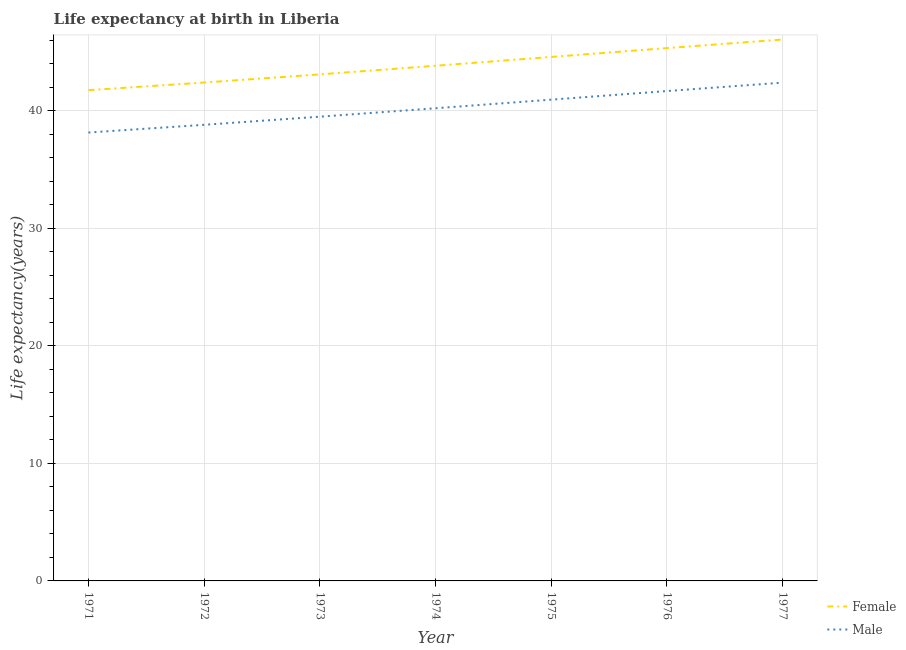How many different coloured lines are there?
Keep it short and to the point. 2. Does the line corresponding to life expectancy(male) intersect with the line corresponding to life expectancy(female)?
Give a very brief answer. No. What is the life expectancy(male) in 1975?
Your answer should be very brief. 40.95. Across all years, what is the maximum life expectancy(male)?
Your answer should be very brief. 42.4. Across all years, what is the minimum life expectancy(female)?
Ensure brevity in your answer.  41.76. In which year was the life expectancy(female) minimum?
Offer a very short reply. 1971. What is the total life expectancy(female) in the graph?
Make the answer very short. 307.11. What is the difference between the life expectancy(female) in 1976 and that in 1977?
Provide a succinct answer. -0.73. What is the difference between the life expectancy(female) in 1974 and the life expectancy(male) in 1975?
Keep it short and to the point. 2.89. What is the average life expectancy(female) per year?
Offer a terse response. 43.87. In the year 1972, what is the difference between the life expectancy(male) and life expectancy(female)?
Make the answer very short. -3.6. What is the ratio of the life expectancy(female) in 1972 to that in 1975?
Keep it short and to the point. 0.95. Is the life expectancy(male) in 1973 less than that in 1975?
Your answer should be compact. Yes. What is the difference between the highest and the second highest life expectancy(male)?
Your answer should be very brief. 0.72. What is the difference between the highest and the lowest life expectancy(female)?
Offer a terse response. 4.31. In how many years, is the life expectancy(male) greater than the average life expectancy(male) taken over all years?
Ensure brevity in your answer.  3. Does the life expectancy(female) monotonically increase over the years?
Keep it short and to the point. Yes. Is the life expectancy(female) strictly greater than the life expectancy(male) over the years?
Provide a succinct answer. Yes. How many years are there in the graph?
Provide a short and direct response. 7. What is the difference between two consecutive major ticks on the Y-axis?
Your answer should be very brief. 10. Are the values on the major ticks of Y-axis written in scientific E-notation?
Offer a terse response. No. Does the graph contain grids?
Provide a short and direct response. Yes. Where does the legend appear in the graph?
Provide a short and direct response. Bottom right. How are the legend labels stacked?
Provide a succinct answer. Vertical. What is the title of the graph?
Provide a succinct answer. Life expectancy at birth in Liberia. Does "Net National savings" appear as one of the legend labels in the graph?
Your response must be concise. No. What is the label or title of the X-axis?
Give a very brief answer. Year. What is the label or title of the Y-axis?
Make the answer very short. Life expectancy(years). What is the Life expectancy(years) of Female in 1971?
Give a very brief answer. 41.76. What is the Life expectancy(years) in Male in 1971?
Your answer should be compact. 38.16. What is the Life expectancy(years) of Female in 1972?
Your answer should be compact. 42.41. What is the Life expectancy(years) in Male in 1972?
Ensure brevity in your answer.  38.81. What is the Life expectancy(years) in Female in 1973?
Provide a short and direct response. 43.1. What is the Life expectancy(years) in Male in 1973?
Offer a very short reply. 39.5. What is the Life expectancy(years) of Female in 1974?
Make the answer very short. 43.84. What is the Life expectancy(years) of Male in 1974?
Offer a terse response. 40.22. What is the Life expectancy(years) of Female in 1975?
Give a very brief answer. 44.59. What is the Life expectancy(years) of Male in 1975?
Ensure brevity in your answer.  40.95. What is the Life expectancy(years) of Female in 1976?
Give a very brief answer. 45.34. What is the Life expectancy(years) in Male in 1976?
Provide a short and direct response. 41.69. What is the Life expectancy(years) of Female in 1977?
Provide a succinct answer. 46.07. What is the Life expectancy(years) of Male in 1977?
Offer a very short reply. 42.4. Across all years, what is the maximum Life expectancy(years) in Female?
Keep it short and to the point. 46.07. Across all years, what is the maximum Life expectancy(years) of Male?
Make the answer very short. 42.4. Across all years, what is the minimum Life expectancy(years) in Female?
Offer a very short reply. 41.76. Across all years, what is the minimum Life expectancy(years) in Male?
Your answer should be compact. 38.16. What is the total Life expectancy(years) in Female in the graph?
Ensure brevity in your answer.  307.11. What is the total Life expectancy(years) of Male in the graph?
Your answer should be compact. 281.73. What is the difference between the Life expectancy(years) in Female in 1971 and that in 1972?
Provide a succinct answer. -0.65. What is the difference between the Life expectancy(years) in Male in 1971 and that in 1972?
Make the answer very short. -0.66. What is the difference between the Life expectancy(years) in Female in 1971 and that in 1973?
Provide a succinct answer. -1.34. What is the difference between the Life expectancy(years) in Male in 1971 and that in 1973?
Offer a terse response. -1.35. What is the difference between the Life expectancy(years) in Female in 1971 and that in 1974?
Your answer should be very brief. -2.08. What is the difference between the Life expectancy(years) in Male in 1971 and that in 1974?
Make the answer very short. -2.06. What is the difference between the Life expectancy(years) of Female in 1971 and that in 1975?
Your response must be concise. -2.83. What is the difference between the Life expectancy(years) in Male in 1971 and that in 1975?
Make the answer very short. -2.8. What is the difference between the Life expectancy(years) of Female in 1971 and that in 1976?
Your answer should be compact. -3.58. What is the difference between the Life expectancy(years) of Male in 1971 and that in 1976?
Make the answer very short. -3.53. What is the difference between the Life expectancy(years) in Female in 1971 and that in 1977?
Provide a succinct answer. -4.31. What is the difference between the Life expectancy(years) in Male in 1971 and that in 1977?
Offer a very short reply. -4.25. What is the difference between the Life expectancy(years) in Female in 1972 and that in 1973?
Make the answer very short. -0.7. What is the difference between the Life expectancy(years) in Male in 1972 and that in 1973?
Provide a succinct answer. -0.69. What is the difference between the Life expectancy(years) of Female in 1972 and that in 1974?
Keep it short and to the point. -1.43. What is the difference between the Life expectancy(years) of Male in 1972 and that in 1974?
Your answer should be very brief. -1.41. What is the difference between the Life expectancy(years) in Female in 1972 and that in 1975?
Provide a succinct answer. -2.18. What is the difference between the Life expectancy(years) of Male in 1972 and that in 1975?
Give a very brief answer. -2.14. What is the difference between the Life expectancy(years) of Female in 1972 and that in 1976?
Your answer should be very brief. -2.93. What is the difference between the Life expectancy(years) of Male in 1972 and that in 1976?
Provide a short and direct response. -2.87. What is the difference between the Life expectancy(years) in Female in 1972 and that in 1977?
Your response must be concise. -3.66. What is the difference between the Life expectancy(years) in Male in 1972 and that in 1977?
Provide a succinct answer. -3.59. What is the difference between the Life expectancy(years) in Female in 1973 and that in 1974?
Make the answer very short. -0.73. What is the difference between the Life expectancy(years) of Male in 1973 and that in 1974?
Your response must be concise. -0.72. What is the difference between the Life expectancy(years) in Female in 1973 and that in 1975?
Provide a short and direct response. -1.48. What is the difference between the Life expectancy(years) of Male in 1973 and that in 1975?
Your response must be concise. -1.45. What is the difference between the Life expectancy(years) in Female in 1973 and that in 1976?
Provide a succinct answer. -2.24. What is the difference between the Life expectancy(years) in Male in 1973 and that in 1976?
Your answer should be very brief. -2.18. What is the difference between the Life expectancy(years) of Female in 1973 and that in 1977?
Provide a short and direct response. -2.96. What is the difference between the Life expectancy(years) in Male in 1973 and that in 1977?
Provide a succinct answer. -2.9. What is the difference between the Life expectancy(years) in Female in 1974 and that in 1975?
Your answer should be compact. -0.75. What is the difference between the Life expectancy(years) of Male in 1974 and that in 1975?
Keep it short and to the point. -0.73. What is the difference between the Life expectancy(years) in Female in 1974 and that in 1976?
Keep it short and to the point. -1.5. What is the difference between the Life expectancy(years) in Male in 1974 and that in 1976?
Keep it short and to the point. -1.47. What is the difference between the Life expectancy(years) of Female in 1974 and that in 1977?
Ensure brevity in your answer.  -2.23. What is the difference between the Life expectancy(years) in Male in 1974 and that in 1977?
Offer a very short reply. -2.18. What is the difference between the Life expectancy(years) in Female in 1975 and that in 1976?
Keep it short and to the point. -0.75. What is the difference between the Life expectancy(years) in Male in 1975 and that in 1976?
Provide a short and direct response. -0.73. What is the difference between the Life expectancy(years) of Female in 1975 and that in 1977?
Your answer should be compact. -1.48. What is the difference between the Life expectancy(years) in Male in 1975 and that in 1977?
Your answer should be very brief. -1.45. What is the difference between the Life expectancy(years) in Female in 1976 and that in 1977?
Provide a succinct answer. -0.73. What is the difference between the Life expectancy(years) of Male in 1976 and that in 1977?
Provide a succinct answer. -0.72. What is the difference between the Life expectancy(years) of Female in 1971 and the Life expectancy(years) of Male in 1972?
Provide a succinct answer. 2.95. What is the difference between the Life expectancy(years) of Female in 1971 and the Life expectancy(years) of Male in 1973?
Provide a short and direct response. 2.26. What is the difference between the Life expectancy(years) in Female in 1971 and the Life expectancy(years) in Male in 1974?
Provide a short and direct response. 1.54. What is the difference between the Life expectancy(years) of Female in 1971 and the Life expectancy(years) of Male in 1975?
Give a very brief answer. 0.81. What is the difference between the Life expectancy(years) in Female in 1971 and the Life expectancy(years) in Male in 1976?
Your answer should be compact. 0.07. What is the difference between the Life expectancy(years) in Female in 1971 and the Life expectancy(years) in Male in 1977?
Offer a very short reply. -0.64. What is the difference between the Life expectancy(years) in Female in 1972 and the Life expectancy(years) in Male in 1973?
Provide a succinct answer. 2.9. What is the difference between the Life expectancy(years) of Female in 1972 and the Life expectancy(years) of Male in 1974?
Give a very brief answer. 2.19. What is the difference between the Life expectancy(years) of Female in 1972 and the Life expectancy(years) of Male in 1975?
Offer a terse response. 1.46. What is the difference between the Life expectancy(years) of Female in 1972 and the Life expectancy(years) of Male in 1976?
Offer a terse response. 0.72. What is the difference between the Life expectancy(years) in Female in 1972 and the Life expectancy(years) in Male in 1977?
Provide a succinct answer. 0.01. What is the difference between the Life expectancy(years) of Female in 1973 and the Life expectancy(years) of Male in 1974?
Provide a short and direct response. 2.88. What is the difference between the Life expectancy(years) in Female in 1973 and the Life expectancy(years) in Male in 1975?
Give a very brief answer. 2.15. What is the difference between the Life expectancy(years) in Female in 1973 and the Life expectancy(years) in Male in 1976?
Give a very brief answer. 1.42. What is the difference between the Life expectancy(years) in Female in 1973 and the Life expectancy(years) in Male in 1977?
Provide a succinct answer. 0.7. What is the difference between the Life expectancy(years) in Female in 1974 and the Life expectancy(years) in Male in 1975?
Offer a terse response. 2.88. What is the difference between the Life expectancy(years) of Female in 1974 and the Life expectancy(years) of Male in 1976?
Provide a succinct answer. 2.15. What is the difference between the Life expectancy(years) of Female in 1974 and the Life expectancy(years) of Male in 1977?
Your response must be concise. 1.44. What is the difference between the Life expectancy(years) of Female in 1975 and the Life expectancy(years) of Male in 1976?
Offer a very short reply. 2.9. What is the difference between the Life expectancy(years) in Female in 1975 and the Life expectancy(years) in Male in 1977?
Your answer should be very brief. 2.19. What is the difference between the Life expectancy(years) of Female in 1976 and the Life expectancy(years) of Male in 1977?
Give a very brief answer. 2.94. What is the average Life expectancy(years) in Female per year?
Ensure brevity in your answer.  43.87. What is the average Life expectancy(years) of Male per year?
Ensure brevity in your answer.  40.25. In the year 1971, what is the difference between the Life expectancy(years) of Female and Life expectancy(years) of Male?
Your response must be concise. 3.6. In the year 1972, what is the difference between the Life expectancy(years) in Female and Life expectancy(years) in Male?
Provide a short and direct response. 3.6. In the year 1974, what is the difference between the Life expectancy(years) in Female and Life expectancy(years) in Male?
Give a very brief answer. 3.62. In the year 1975, what is the difference between the Life expectancy(years) of Female and Life expectancy(years) of Male?
Offer a very short reply. 3.64. In the year 1976, what is the difference between the Life expectancy(years) of Female and Life expectancy(years) of Male?
Your response must be concise. 3.65. In the year 1977, what is the difference between the Life expectancy(years) in Female and Life expectancy(years) in Male?
Your response must be concise. 3.67. What is the ratio of the Life expectancy(years) in Female in 1971 to that in 1972?
Provide a short and direct response. 0.98. What is the ratio of the Life expectancy(years) of Male in 1971 to that in 1972?
Make the answer very short. 0.98. What is the ratio of the Life expectancy(years) in Female in 1971 to that in 1973?
Your answer should be very brief. 0.97. What is the ratio of the Life expectancy(years) of Male in 1971 to that in 1973?
Offer a terse response. 0.97. What is the ratio of the Life expectancy(years) of Female in 1971 to that in 1974?
Ensure brevity in your answer.  0.95. What is the ratio of the Life expectancy(years) of Male in 1971 to that in 1974?
Ensure brevity in your answer.  0.95. What is the ratio of the Life expectancy(years) in Female in 1971 to that in 1975?
Ensure brevity in your answer.  0.94. What is the ratio of the Life expectancy(years) in Male in 1971 to that in 1975?
Offer a very short reply. 0.93. What is the ratio of the Life expectancy(years) in Female in 1971 to that in 1976?
Your response must be concise. 0.92. What is the ratio of the Life expectancy(years) in Male in 1971 to that in 1976?
Provide a succinct answer. 0.92. What is the ratio of the Life expectancy(years) in Female in 1971 to that in 1977?
Your response must be concise. 0.91. What is the ratio of the Life expectancy(years) in Male in 1971 to that in 1977?
Your answer should be very brief. 0.9. What is the ratio of the Life expectancy(years) of Female in 1972 to that in 1973?
Give a very brief answer. 0.98. What is the ratio of the Life expectancy(years) in Male in 1972 to that in 1973?
Give a very brief answer. 0.98. What is the ratio of the Life expectancy(years) in Female in 1972 to that in 1974?
Provide a short and direct response. 0.97. What is the ratio of the Life expectancy(years) of Female in 1972 to that in 1975?
Ensure brevity in your answer.  0.95. What is the ratio of the Life expectancy(years) in Male in 1972 to that in 1975?
Keep it short and to the point. 0.95. What is the ratio of the Life expectancy(years) of Female in 1972 to that in 1976?
Your response must be concise. 0.94. What is the ratio of the Life expectancy(years) of Male in 1972 to that in 1976?
Ensure brevity in your answer.  0.93. What is the ratio of the Life expectancy(years) in Female in 1972 to that in 1977?
Offer a very short reply. 0.92. What is the ratio of the Life expectancy(years) in Male in 1972 to that in 1977?
Ensure brevity in your answer.  0.92. What is the ratio of the Life expectancy(years) in Female in 1973 to that in 1974?
Your response must be concise. 0.98. What is the ratio of the Life expectancy(years) in Male in 1973 to that in 1974?
Offer a very short reply. 0.98. What is the ratio of the Life expectancy(years) of Female in 1973 to that in 1975?
Your response must be concise. 0.97. What is the ratio of the Life expectancy(years) in Male in 1973 to that in 1975?
Offer a very short reply. 0.96. What is the ratio of the Life expectancy(years) of Female in 1973 to that in 1976?
Your answer should be compact. 0.95. What is the ratio of the Life expectancy(years) of Male in 1973 to that in 1976?
Your response must be concise. 0.95. What is the ratio of the Life expectancy(years) of Female in 1973 to that in 1977?
Your response must be concise. 0.94. What is the ratio of the Life expectancy(years) of Male in 1973 to that in 1977?
Offer a terse response. 0.93. What is the ratio of the Life expectancy(years) of Female in 1974 to that in 1975?
Your response must be concise. 0.98. What is the ratio of the Life expectancy(years) in Male in 1974 to that in 1975?
Provide a short and direct response. 0.98. What is the ratio of the Life expectancy(years) in Female in 1974 to that in 1976?
Your answer should be very brief. 0.97. What is the ratio of the Life expectancy(years) in Male in 1974 to that in 1976?
Ensure brevity in your answer.  0.96. What is the ratio of the Life expectancy(years) of Female in 1974 to that in 1977?
Your response must be concise. 0.95. What is the ratio of the Life expectancy(years) of Male in 1974 to that in 1977?
Offer a very short reply. 0.95. What is the ratio of the Life expectancy(years) of Female in 1975 to that in 1976?
Offer a terse response. 0.98. What is the ratio of the Life expectancy(years) in Male in 1975 to that in 1976?
Make the answer very short. 0.98. What is the ratio of the Life expectancy(years) of Female in 1975 to that in 1977?
Keep it short and to the point. 0.97. What is the ratio of the Life expectancy(years) in Male in 1975 to that in 1977?
Provide a short and direct response. 0.97. What is the ratio of the Life expectancy(years) in Female in 1976 to that in 1977?
Provide a succinct answer. 0.98. What is the ratio of the Life expectancy(years) in Male in 1976 to that in 1977?
Provide a short and direct response. 0.98. What is the difference between the highest and the second highest Life expectancy(years) in Female?
Offer a terse response. 0.73. What is the difference between the highest and the second highest Life expectancy(years) in Male?
Keep it short and to the point. 0.72. What is the difference between the highest and the lowest Life expectancy(years) in Female?
Your response must be concise. 4.31. What is the difference between the highest and the lowest Life expectancy(years) in Male?
Keep it short and to the point. 4.25. 